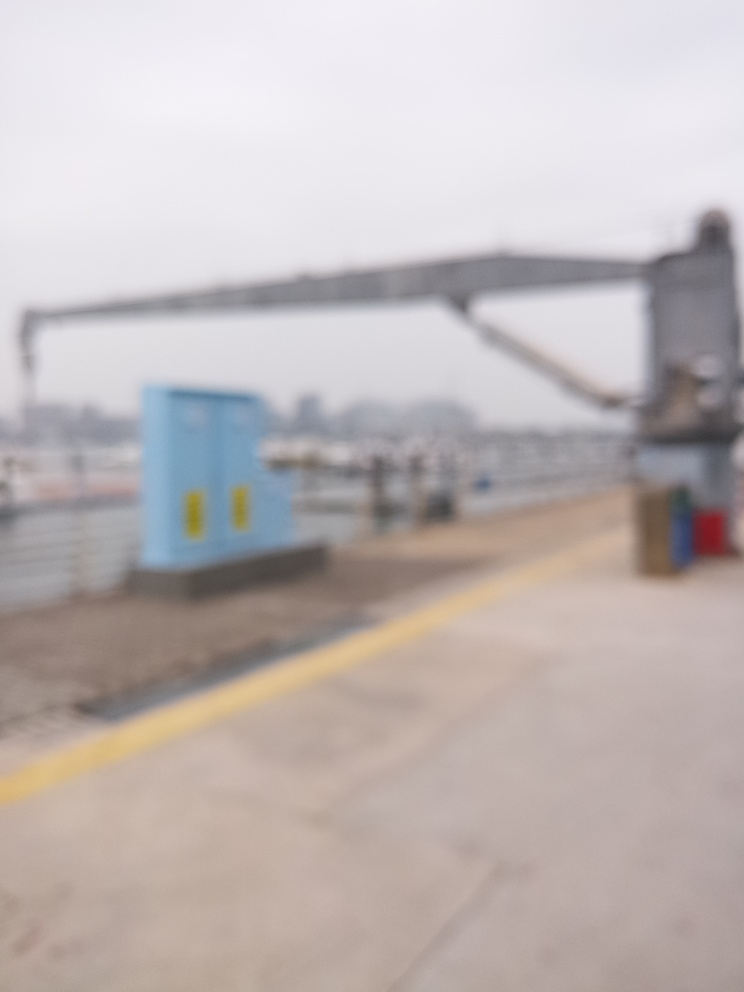What kind of colors are present in this picture?
A. monotonous
B. vibrant
C. varied
D. complementary Unfortunately, the image is quite blurry, and it is challenging to make out the specific colors with confidence. However, the impression it gives is not vibrant but rather monotonous due to the lack of distinguishable features and colors. So while answer A is somewhat accurate given that information, a more nuanced assessment of color scheme could not be provided in this instance. 